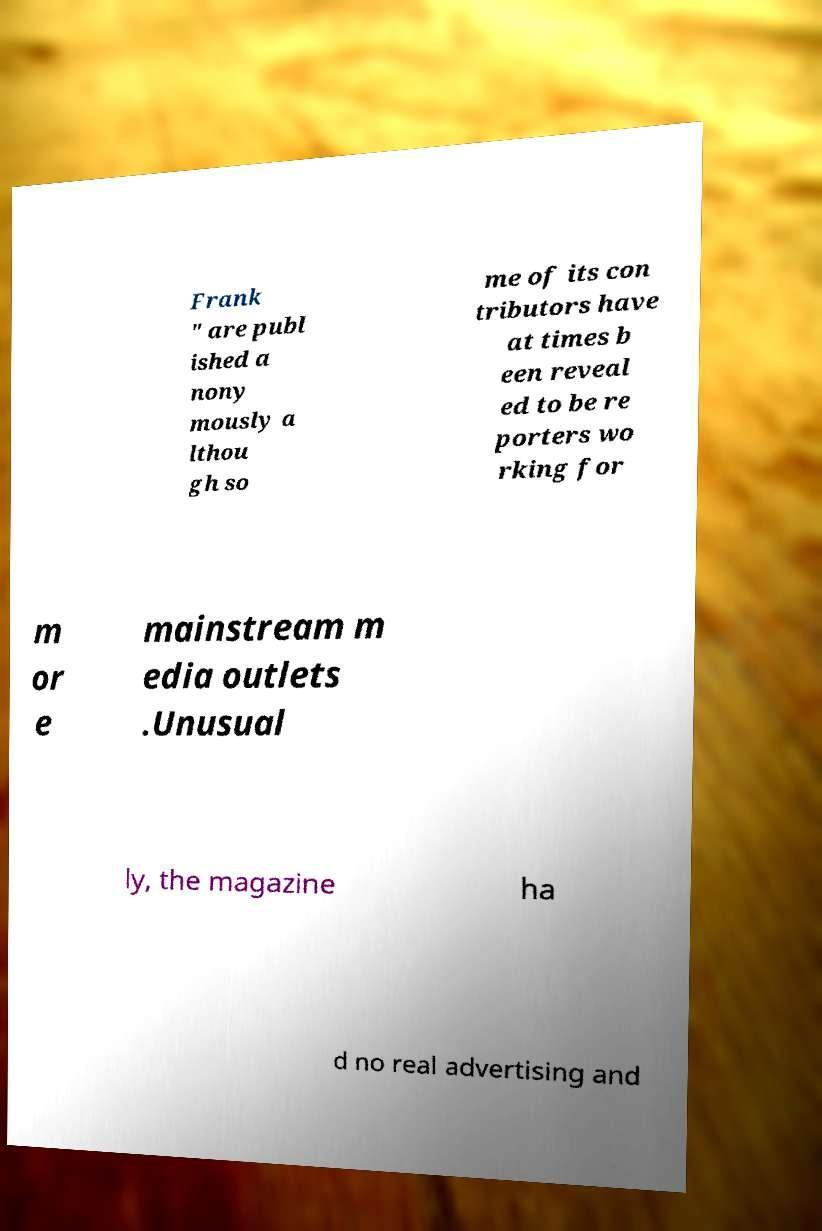There's text embedded in this image that I need extracted. Can you transcribe it verbatim? Frank " are publ ished a nony mously a lthou gh so me of its con tributors have at times b een reveal ed to be re porters wo rking for m or e mainstream m edia outlets .Unusual ly, the magazine ha d no real advertising and 